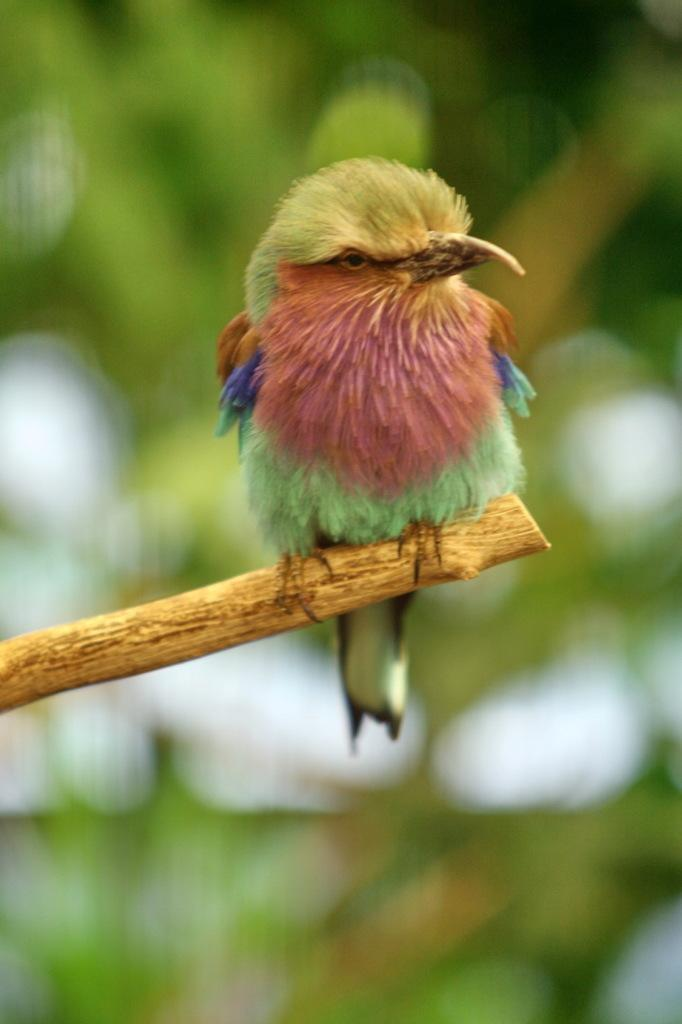What type of animal can be seen in the image? There is a bird in the image. Where is the bird positioned in the image? The bird is on a branch. Can you describe the bird's location in relation to the image? The bird is located in the center of the image. What type of twig is the bird using to drink milk in the image? There is no twig or milk present in the image; it features a bird on a branch. What type of sponge is the bird holding in the image? There is no sponge present in the image; it features a bird on a branch. 